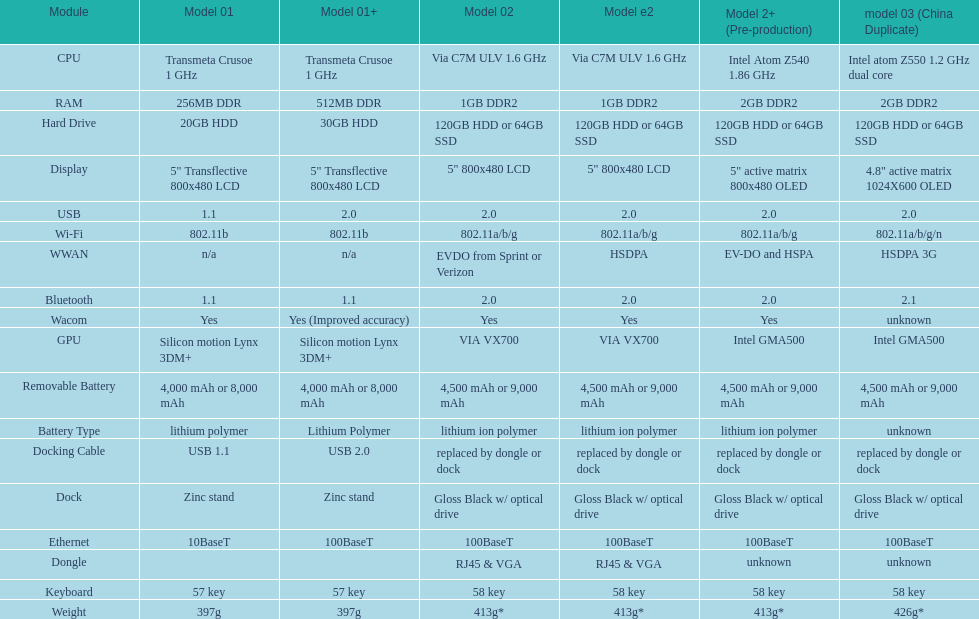What is the component before usb? Display. 